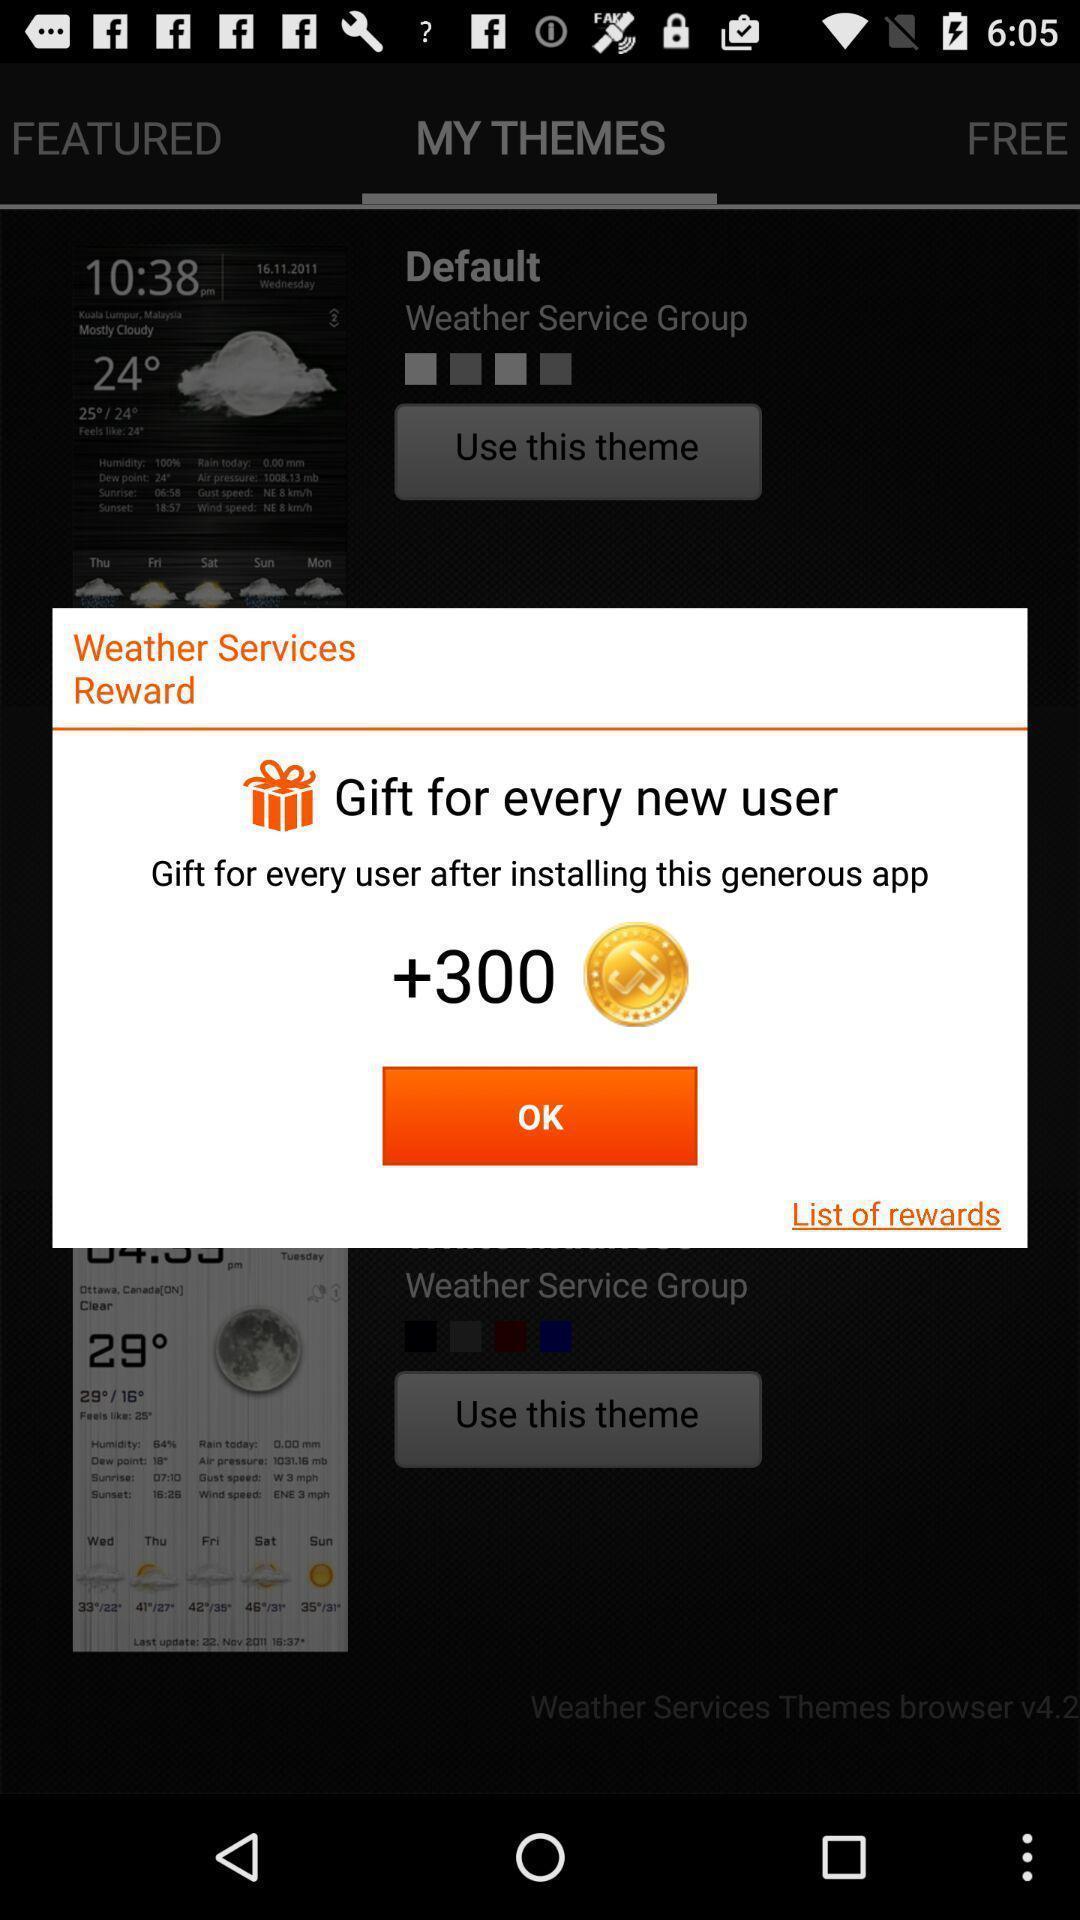What can you discern from this picture? Pop-up displaying with reward points. 